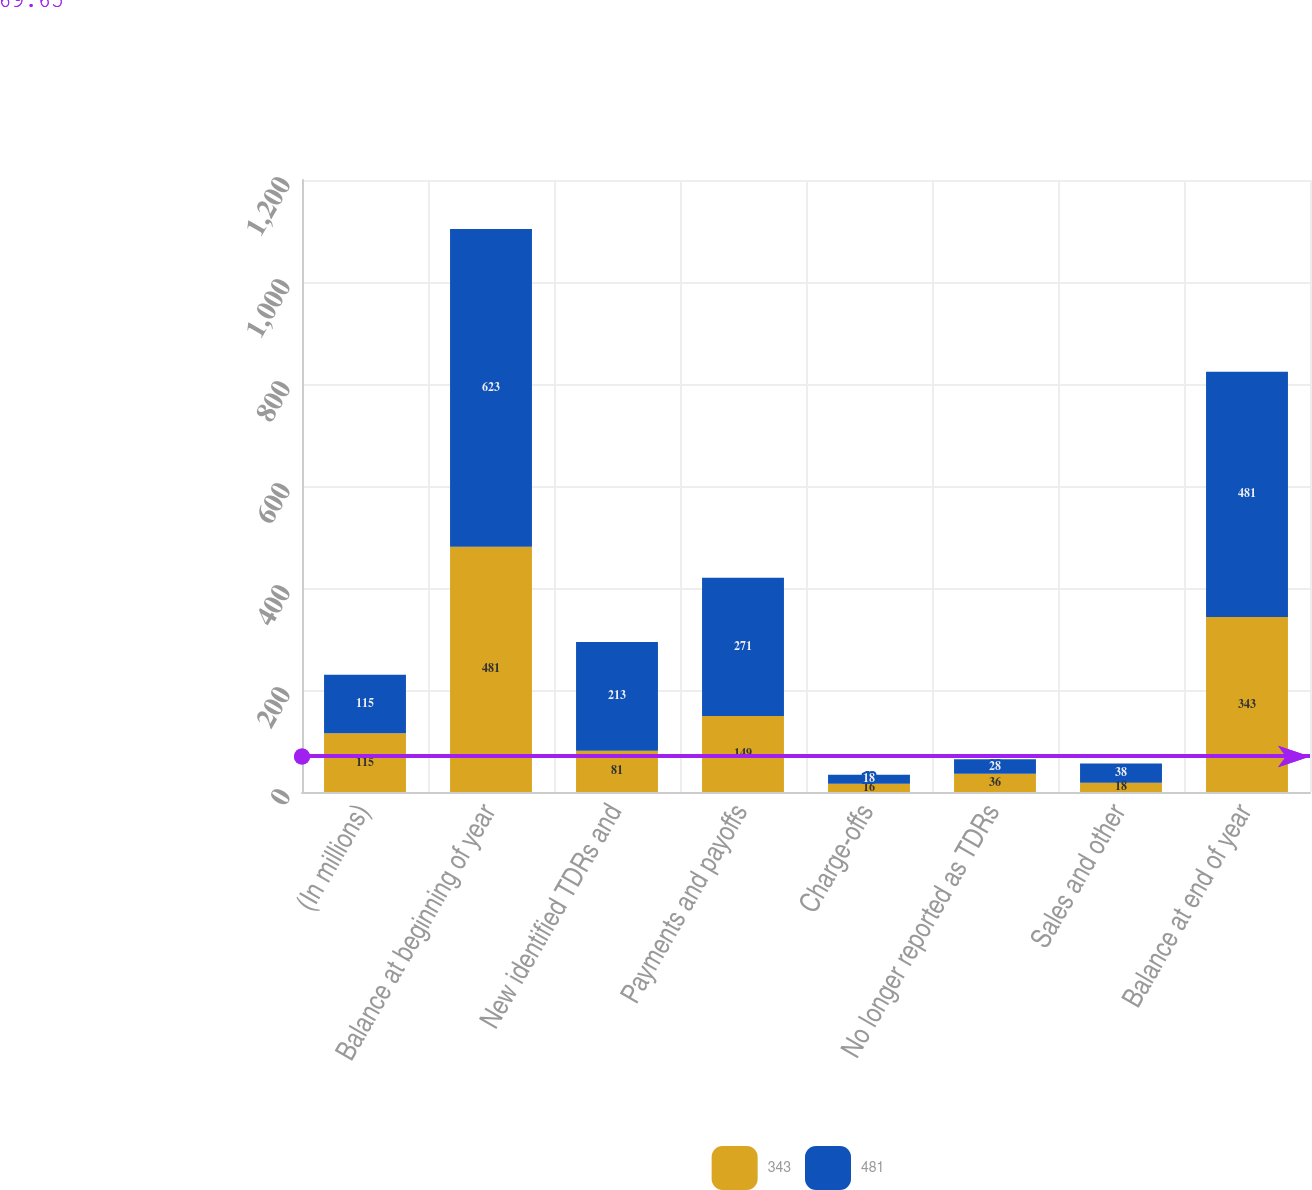<chart> <loc_0><loc_0><loc_500><loc_500><stacked_bar_chart><ecel><fcel>(In millions)<fcel>Balance at beginning of year<fcel>New identified TDRs and<fcel>Payments and payoffs<fcel>Charge-offs<fcel>No longer reported as TDRs<fcel>Sales and other<fcel>Balance at end of year<nl><fcel>343<fcel>115<fcel>481<fcel>81<fcel>149<fcel>16<fcel>36<fcel>18<fcel>343<nl><fcel>481<fcel>115<fcel>623<fcel>213<fcel>271<fcel>18<fcel>28<fcel>38<fcel>481<nl></chart> 